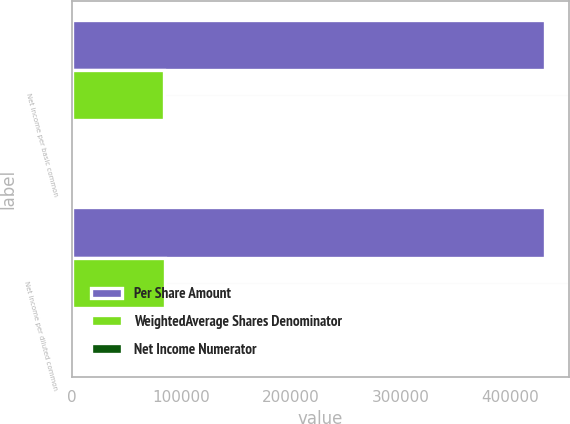Convert chart. <chart><loc_0><loc_0><loc_500><loc_500><stacked_bar_chart><ecel><fcel>Net income per basic common<fcel>Net income per diluted common<nl><fcel>Per Share Amount<fcel>431620<fcel>431620<nl><fcel>WeightedAverage Shares Denominator<fcel>84358<fcel>85151<nl><fcel>Net Income Numerator<fcel>5.12<fcel>5.07<nl></chart> 